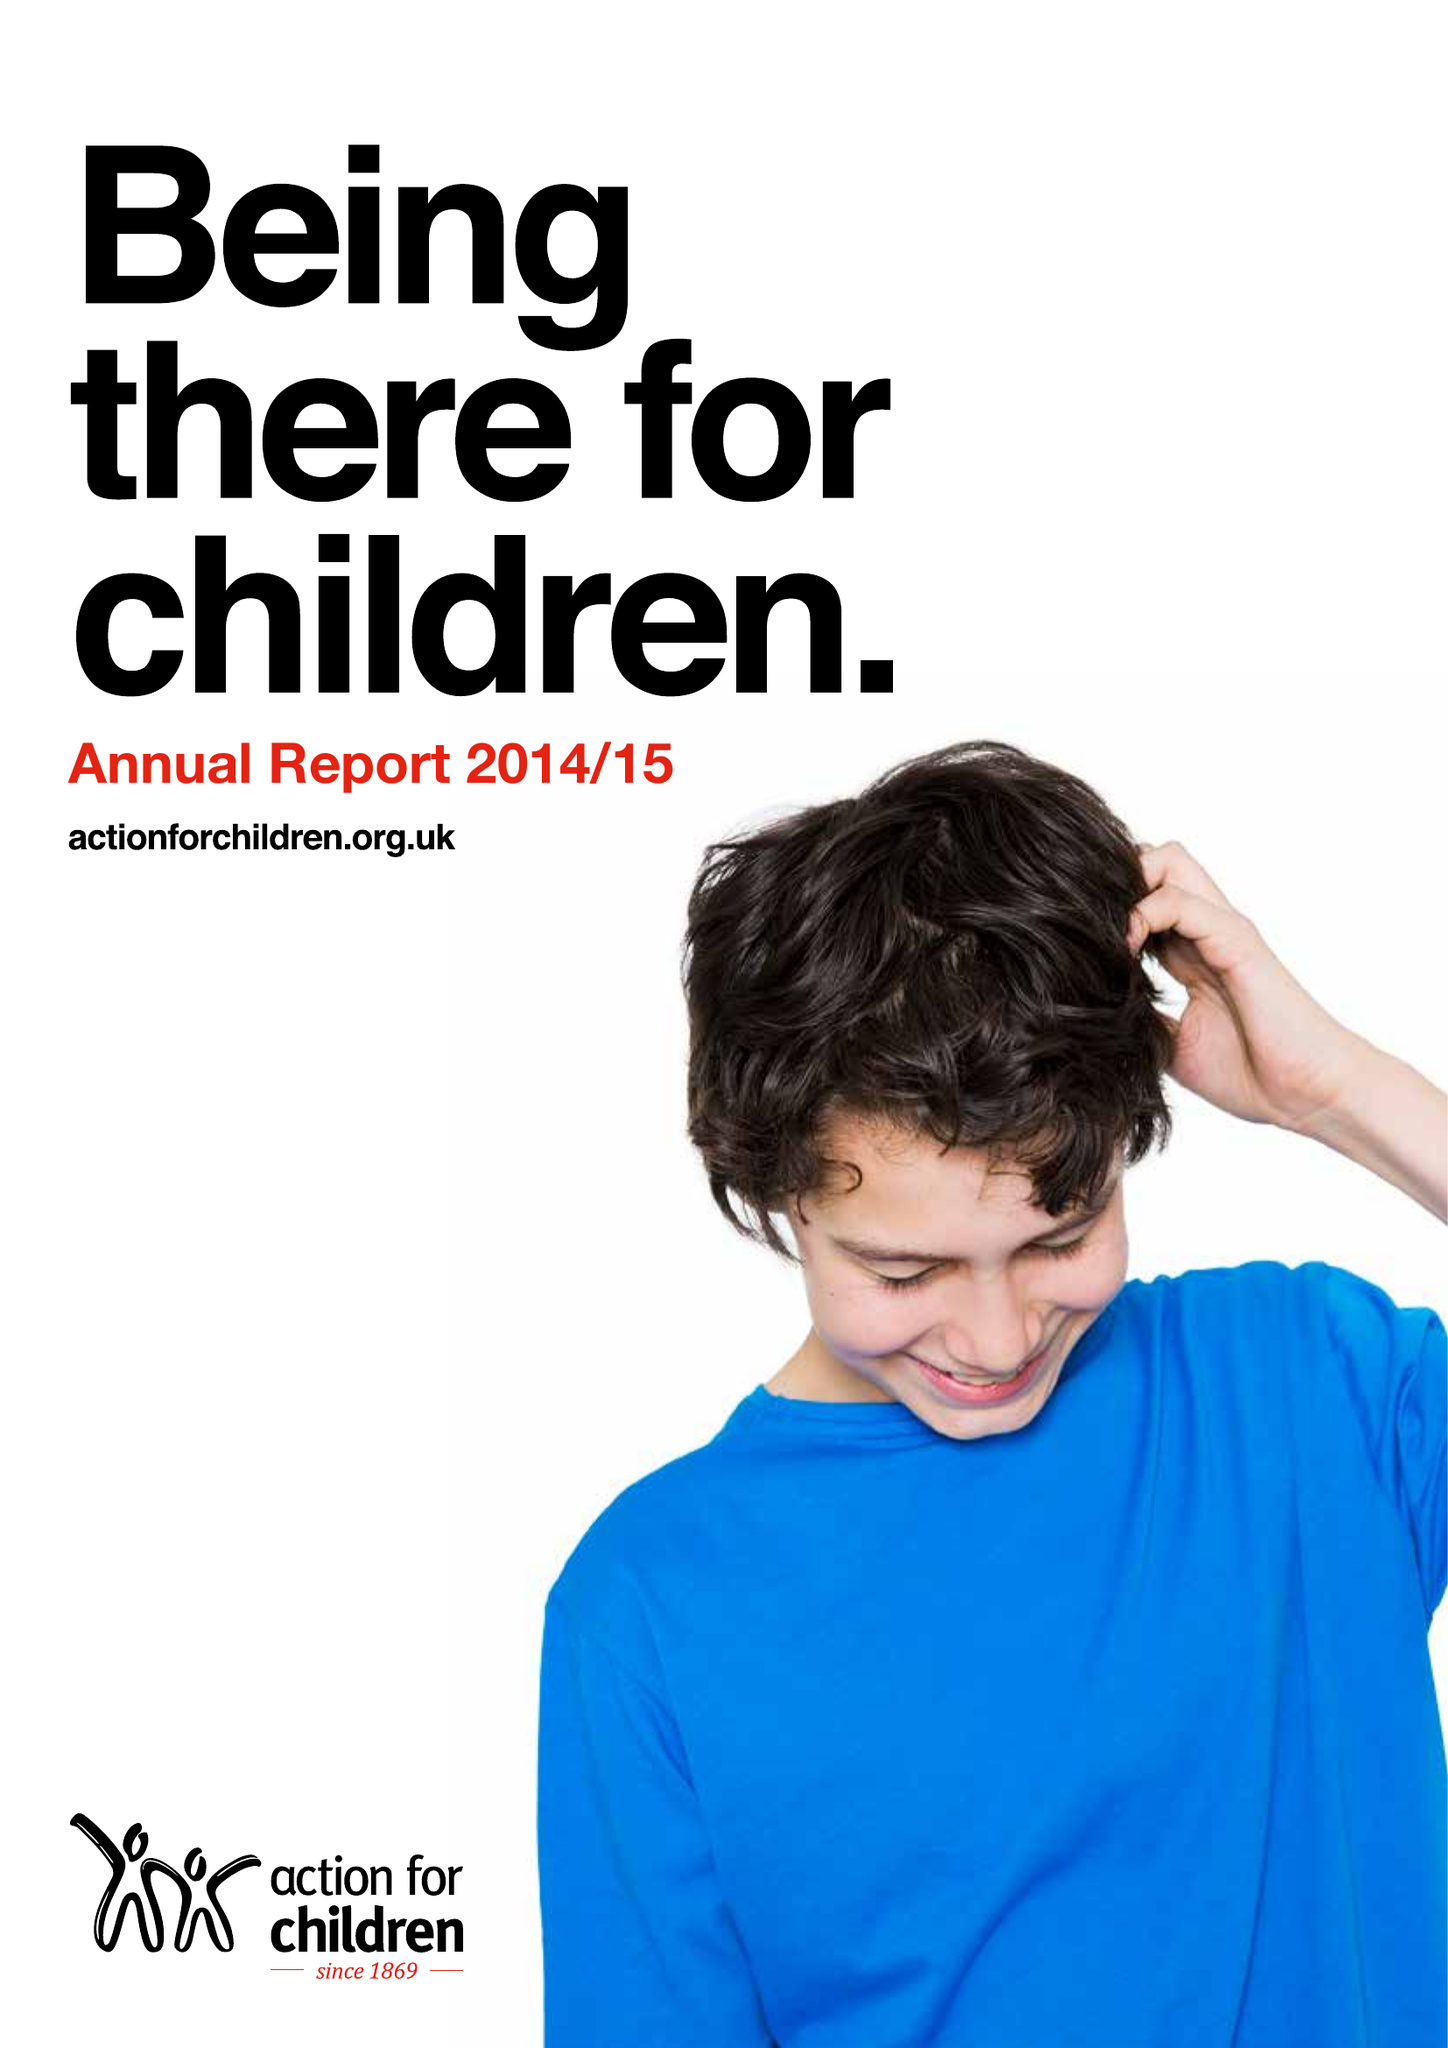What is the value for the report_date?
Answer the question using a single word or phrase. 2015-03-31 